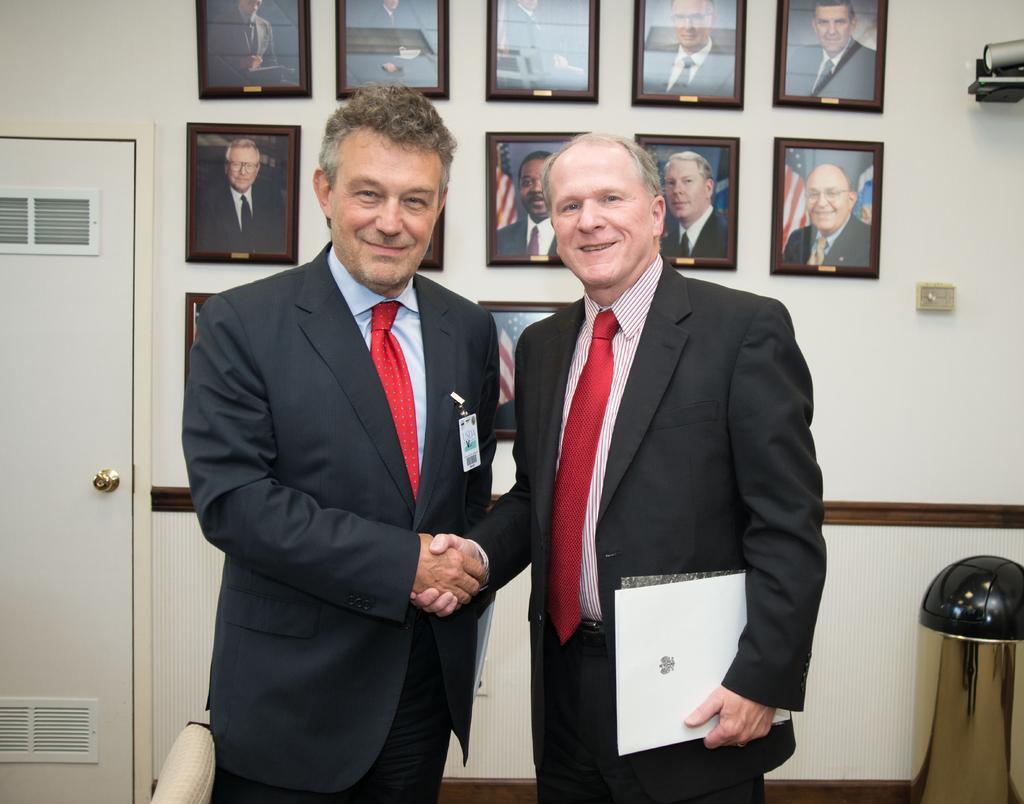In one or two sentences, can you explain what this image depicts? In this image we can see persons standing on the floor. In the background we can see photo frames, door, dustbin and wall. 